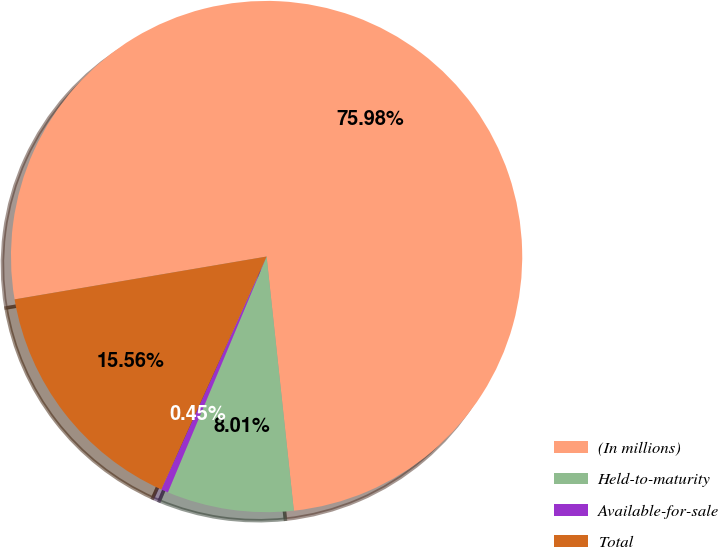<chart> <loc_0><loc_0><loc_500><loc_500><pie_chart><fcel>(In millions)<fcel>Held-to-maturity<fcel>Available-for-sale<fcel>Total<nl><fcel>75.98%<fcel>8.01%<fcel>0.45%<fcel>15.56%<nl></chart> 